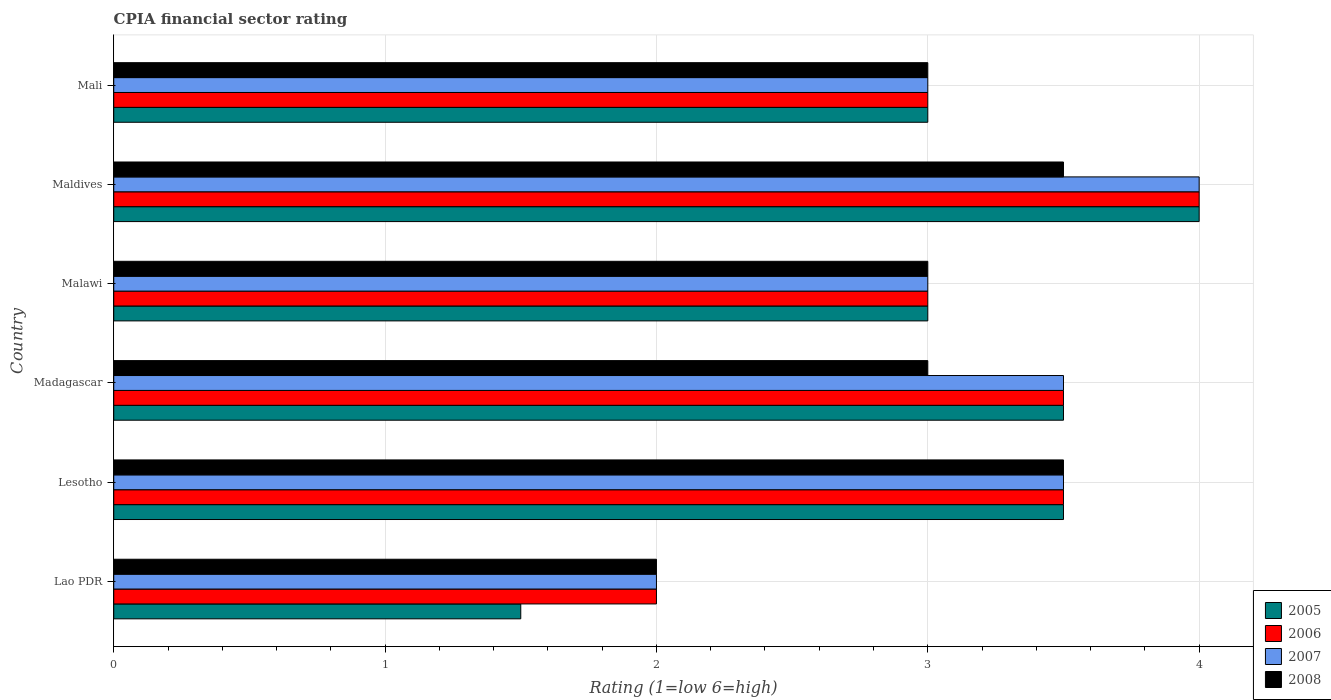How many different coloured bars are there?
Offer a very short reply. 4. How many groups of bars are there?
Your answer should be compact. 6. How many bars are there on the 5th tick from the bottom?
Provide a succinct answer. 4. What is the label of the 5th group of bars from the top?
Make the answer very short. Lesotho. What is the CPIA rating in 2007 in Lesotho?
Offer a terse response. 3.5. In which country was the CPIA rating in 2005 maximum?
Make the answer very short. Maldives. In which country was the CPIA rating in 2008 minimum?
Provide a succinct answer. Lao PDR. What is the total CPIA rating in 2008 in the graph?
Make the answer very short. 18. What is the difference between the CPIA rating in 2008 in Madagascar and that in Mali?
Offer a terse response. 0. What is the difference between the CPIA rating in 2008 in Maldives and the CPIA rating in 2006 in Madagascar?
Provide a short and direct response. 0. What is the difference between the CPIA rating in 2007 and CPIA rating in 2005 in Maldives?
Keep it short and to the point. 0. In how many countries, is the CPIA rating in 2006 greater than 1.8 ?
Offer a terse response. 6. What is the ratio of the CPIA rating in 2008 in Lesotho to that in Mali?
Give a very brief answer. 1.17. Is the CPIA rating in 2008 in Lesotho less than that in Madagascar?
Your response must be concise. No. What is the difference between the highest and the second highest CPIA rating in 2007?
Your answer should be very brief. 0.5. What is the difference between the highest and the lowest CPIA rating in 2006?
Ensure brevity in your answer.  2. Is it the case that in every country, the sum of the CPIA rating in 2005 and CPIA rating in 2006 is greater than the sum of CPIA rating in 2008 and CPIA rating in 2007?
Make the answer very short. No. What does the 1st bar from the top in Madagascar represents?
Your answer should be compact. 2008. What does the 2nd bar from the bottom in Madagascar represents?
Make the answer very short. 2006. What is the difference between two consecutive major ticks on the X-axis?
Your answer should be compact. 1. Where does the legend appear in the graph?
Keep it short and to the point. Bottom right. How many legend labels are there?
Your response must be concise. 4. What is the title of the graph?
Provide a succinct answer. CPIA financial sector rating. Does "1997" appear as one of the legend labels in the graph?
Keep it short and to the point. No. What is the label or title of the X-axis?
Give a very brief answer. Rating (1=low 6=high). What is the label or title of the Y-axis?
Your answer should be very brief. Country. What is the Rating (1=low 6=high) of 2005 in Lao PDR?
Make the answer very short. 1.5. What is the Rating (1=low 6=high) in 2006 in Lesotho?
Offer a terse response. 3.5. What is the Rating (1=low 6=high) in 2007 in Lesotho?
Ensure brevity in your answer.  3.5. What is the Rating (1=low 6=high) of 2005 in Madagascar?
Give a very brief answer. 3.5. What is the Rating (1=low 6=high) of 2006 in Madagascar?
Your response must be concise. 3.5. What is the Rating (1=low 6=high) in 2007 in Madagascar?
Give a very brief answer. 3.5. What is the Rating (1=low 6=high) of 2008 in Madagascar?
Provide a short and direct response. 3. What is the Rating (1=low 6=high) of 2005 in Malawi?
Ensure brevity in your answer.  3. What is the Rating (1=low 6=high) of 2007 in Malawi?
Make the answer very short. 3. What is the Rating (1=low 6=high) of 2008 in Malawi?
Give a very brief answer. 3. What is the Rating (1=low 6=high) of 2008 in Maldives?
Ensure brevity in your answer.  3.5. Across all countries, what is the maximum Rating (1=low 6=high) of 2005?
Give a very brief answer. 4. Across all countries, what is the maximum Rating (1=low 6=high) in 2006?
Ensure brevity in your answer.  4. Across all countries, what is the maximum Rating (1=low 6=high) in 2008?
Ensure brevity in your answer.  3.5. Across all countries, what is the minimum Rating (1=low 6=high) in 2006?
Provide a short and direct response. 2. Across all countries, what is the minimum Rating (1=low 6=high) in 2008?
Ensure brevity in your answer.  2. What is the total Rating (1=low 6=high) in 2005 in the graph?
Provide a short and direct response. 18.5. What is the total Rating (1=low 6=high) in 2006 in the graph?
Your answer should be compact. 19. What is the difference between the Rating (1=low 6=high) in 2005 in Lao PDR and that in Lesotho?
Give a very brief answer. -2. What is the difference between the Rating (1=low 6=high) in 2006 in Lao PDR and that in Lesotho?
Make the answer very short. -1.5. What is the difference between the Rating (1=low 6=high) in 2005 in Lao PDR and that in Madagascar?
Your answer should be compact. -2. What is the difference between the Rating (1=low 6=high) of 2008 in Lao PDR and that in Madagascar?
Your response must be concise. -1. What is the difference between the Rating (1=low 6=high) of 2006 in Lao PDR and that in Malawi?
Keep it short and to the point. -1. What is the difference between the Rating (1=low 6=high) of 2007 in Lao PDR and that in Malawi?
Provide a short and direct response. -1. What is the difference between the Rating (1=low 6=high) in 2008 in Lao PDR and that in Malawi?
Provide a succinct answer. -1. What is the difference between the Rating (1=low 6=high) of 2005 in Lao PDR and that in Maldives?
Offer a terse response. -2.5. What is the difference between the Rating (1=low 6=high) of 2006 in Lao PDR and that in Maldives?
Give a very brief answer. -2. What is the difference between the Rating (1=low 6=high) in 2007 in Lao PDR and that in Maldives?
Your answer should be compact. -2. What is the difference between the Rating (1=low 6=high) in 2008 in Lao PDR and that in Maldives?
Your response must be concise. -1.5. What is the difference between the Rating (1=low 6=high) of 2005 in Lao PDR and that in Mali?
Make the answer very short. -1.5. What is the difference between the Rating (1=low 6=high) in 2008 in Lao PDR and that in Mali?
Ensure brevity in your answer.  -1. What is the difference between the Rating (1=low 6=high) of 2005 in Lesotho and that in Madagascar?
Provide a succinct answer. 0. What is the difference between the Rating (1=low 6=high) of 2006 in Lesotho and that in Madagascar?
Ensure brevity in your answer.  0. What is the difference between the Rating (1=low 6=high) in 2008 in Lesotho and that in Madagascar?
Provide a succinct answer. 0.5. What is the difference between the Rating (1=low 6=high) in 2005 in Lesotho and that in Malawi?
Provide a short and direct response. 0.5. What is the difference between the Rating (1=low 6=high) in 2006 in Lesotho and that in Malawi?
Your answer should be compact. 0.5. What is the difference between the Rating (1=low 6=high) of 2005 in Lesotho and that in Maldives?
Offer a terse response. -0.5. What is the difference between the Rating (1=low 6=high) in 2008 in Lesotho and that in Maldives?
Provide a succinct answer. 0. What is the difference between the Rating (1=low 6=high) of 2006 in Lesotho and that in Mali?
Provide a succinct answer. 0.5. What is the difference between the Rating (1=low 6=high) in 2007 in Lesotho and that in Mali?
Make the answer very short. 0.5. What is the difference between the Rating (1=low 6=high) of 2005 in Madagascar and that in Malawi?
Your answer should be compact. 0.5. What is the difference between the Rating (1=low 6=high) in 2007 in Madagascar and that in Malawi?
Make the answer very short. 0.5. What is the difference between the Rating (1=low 6=high) in 2008 in Madagascar and that in Malawi?
Offer a very short reply. 0. What is the difference between the Rating (1=low 6=high) of 2005 in Madagascar and that in Maldives?
Provide a short and direct response. -0.5. What is the difference between the Rating (1=low 6=high) of 2006 in Madagascar and that in Maldives?
Your response must be concise. -0.5. What is the difference between the Rating (1=low 6=high) of 2007 in Madagascar and that in Maldives?
Provide a short and direct response. -0.5. What is the difference between the Rating (1=low 6=high) of 2008 in Madagascar and that in Maldives?
Keep it short and to the point. -0.5. What is the difference between the Rating (1=low 6=high) of 2005 in Madagascar and that in Mali?
Your answer should be very brief. 0.5. What is the difference between the Rating (1=low 6=high) in 2006 in Madagascar and that in Mali?
Your answer should be compact. 0.5. What is the difference between the Rating (1=low 6=high) of 2007 in Madagascar and that in Mali?
Your answer should be very brief. 0.5. What is the difference between the Rating (1=low 6=high) in 2005 in Malawi and that in Maldives?
Provide a short and direct response. -1. What is the difference between the Rating (1=low 6=high) in 2006 in Malawi and that in Maldives?
Ensure brevity in your answer.  -1. What is the difference between the Rating (1=low 6=high) of 2007 in Malawi and that in Maldives?
Make the answer very short. -1. What is the difference between the Rating (1=low 6=high) of 2005 in Malawi and that in Mali?
Your response must be concise. 0. What is the difference between the Rating (1=low 6=high) in 2007 in Malawi and that in Mali?
Offer a terse response. 0. What is the difference between the Rating (1=low 6=high) of 2008 in Malawi and that in Mali?
Keep it short and to the point. 0. What is the difference between the Rating (1=low 6=high) in 2005 in Maldives and that in Mali?
Your answer should be very brief. 1. What is the difference between the Rating (1=low 6=high) in 2006 in Maldives and that in Mali?
Ensure brevity in your answer.  1. What is the difference between the Rating (1=low 6=high) of 2007 in Maldives and that in Mali?
Your response must be concise. 1. What is the difference between the Rating (1=low 6=high) in 2008 in Maldives and that in Mali?
Ensure brevity in your answer.  0.5. What is the difference between the Rating (1=low 6=high) of 2005 in Lao PDR and the Rating (1=low 6=high) of 2006 in Lesotho?
Give a very brief answer. -2. What is the difference between the Rating (1=low 6=high) in 2005 in Lao PDR and the Rating (1=low 6=high) in 2007 in Lesotho?
Provide a succinct answer. -2. What is the difference between the Rating (1=low 6=high) of 2005 in Lao PDR and the Rating (1=low 6=high) of 2008 in Lesotho?
Your response must be concise. -2. What is the difference between the Rating (1=low 6=high) in 2006 in Lao PDR and the Rating (1=low 6=high) in 2008 in Lesotho?
Ensure brevity in your answer.  -1.5. What is the difference between the Rating (1=low 6=high) in 2007 in Lao PDR and the Rating (1=low 6=high) in 2008 in Lesotho?
Keep it short and to the point. -1.5. What is the difference between the Rating (1=low 6=high) in 2005 in Lao PDR and the Rating (1=low 6=high) in 2007 in Madagascar?
Offer a terse response. -2. What is the difference between the Rating (1=low 6=high) of 2005 in Lao PDR and the Rating (1=low 6=high) of 2008 in Madagascar?
Your answer should be compact. -1.5. What is the difference between the Rating (1=low 6=high) in 2006 in Lao PDR and the Rating (1=low 6=high) in 2007 in Madagascar?
Offer a terse response. -1.5. What is the difference between the Rating (1=low 6=high) of 2006 in Lao PDR and the Rating (1=low 6=high) of 2008 in Madagascar?
Offer a very short reply. -1. What is the difference between the Rating (1=low 6=high) in 2005 in Lao PDR and the Rating (1=low 6=high) in 2007 in Malawi?
Keep it short and to the point. -1.5. What is the difference between the Rating (1=low 6=high) in 2006 in Lao PDR and the Rating (1=low 6=high) in 2007 in Malawi?
Keep it short and to the point. -1. What is the difference between the Rating (1=low 6=high) in 2007 in Lao PDR and the Rating (1=low 6=high) in 2008 in Malawi?
Provide a short and direct response. -1. What is the difference between the Rating (1=low 6=high) in 2005 in Lao PDR and the Rating (1=low 6=high) in 2006 in Maldives?
Make the answer very short. -2.5. What is the difference between the Rating (1=low 6=high) of 2005 in Lao PDR and the Rating (1=low 6=high) of 2007 in Maldives?
Your answer should be very brief. -2.5. What is the difference between the Rating (1=low 6=high) of 2007 in Lao PDR and the Rating (1=low 6=high) of 2008 in Maldives?
Offer a very short reply. -1.5. What is the difference between the Rating (1=low 6=high) of 2005 in Lao PDR and the Rating (1=low 6=high) of 2006 in Mali?
Your answer should be compact. -1.5. What is the difference between the Rating (1=low 6=high) in 2006 in Lao PDR and the Rating (1=low 6=high) in 2007 in Mali?
Your answer should be compact. -1. What is the difference between the Rating (1=low 6=high) of 2006 in Lao PDR and the Rating (1=low 6=high) of 2008 in Mali?
Make the answer very short. -1. What is the difference between the Rating (1=low 6=high) of 2005 in Lesotho and the Rating (1=low 6=high) of 2006 in Madagascar?
Give a very brief answer. 0. What is the difference between the Rating (1=low 6=high) in 2005 in Lesotho and the Rating (1=low 6=high) in 2008 in Madagascar?
Your answer should be very brief. 0.5. What is the difference between the Rating (1=low 6=high) in 2006 in Lesotho and the Rating (1=low 6=high) in 2008 in Madagascar?
Offer a very short reply. 0.5. What is the difference between the Rating (1=low 6=high) in 2007 in Lesotho and the Rating (1=low 6=high) in 2008 in Madagascar?
Your answer should be compact. 0.5. What is the difference between the Rating (1=low 6=high) of 2005 in Lesotho and the Rating (1=low 6=high) of 2007 in Malawi?
Your answer should be compact. 0.5. What is the difference between the Rating (1=low 6=high) in 2006 in Lesotho and the Rating (1=low 6=high) in 2008 in Malawi?
Your response must be concise. 0.5. What is the difference between the Rating (1=low 6=high) in 2007 in Lesotho and the Rating (1=low 6=high) in 2008 in Malawi?
Provide a succinct answer. 0.5. What is the difference between the Rating (1=low 6=high) of 2005 in Lesotho and the Rating (1=low 6=high) of 2006 in Maldives?
Make the answer very short. -0.5. What is the difference between the Rating (1=low 6=high) of 2005 in Lesotho and the Rating (1=low 6=high) of 2007 in Maldives?
Your answer should be very brief. -0.5. What is the difference between the Rating (1=low 6=high) in 2005 in Lesotho and the Rating (1=low 6=high) in 2008 in Maldives?
Offer a very short reply. 0. What is the difference between the Rating (1=low 6=high) in 2006 in Lesotho and the Rating (1=low 6=high) in 2008 in Maldives?
Make the answer very short. 0. What is the difference between the Rating (1=low 6=high) in 2005 in Lesotho and the Rating (1=low 6=high) in 2006 in Mali?
Offer a terse response. 0.5. What is the difference between the Rating (1=low 6=high) in 2005 in Lesotho and the Rating (1=low 6=high) in 2007 in Mali?
Your answer should be compact. 0.5. What is the difference between the Rating (1=low 6=high) in 2006 in Lesotho and the Rating (1=low 6=high) in 2007 in Mali?
Make the answer very short. 0.5. What is the difference between the Rating (1=low 6=high) of 2006 in Lesotho and the Rating (1=low 6=high) of 2008 in Mali?
Make the answer very short. 0.5. What is the difference between the Rating (1=low 6=high) of 2005 in Madagascar and the Rating (1=low 6=high) of 2006 in Malawi?
Keep it short and to the point. 0.5. What is the difference between the Rating (1=low 6=high) of 2005 in Madagascar and the Rating (1=low 6=high) of 2006 in Maldives?
Your answer should be very brief. -0.5. What is the difference between the Rating (1=low 6=high) in 2007 in Madagascar and the Rating (1=low 6=high) in 2008 in Maldives?
Provide a short and direct response. 0. What is the difference between the Rating (1=low 6=high) in 2005 in Madagascar and the Rating (1=low 6=high) in 2006 in Mali?
Ensure brevity in your answer.  0.5. What is the difference between the Rating (1=low 6=high) in 2005 in Madagascar and the Rating (1=low 6=high) in 2007 in Mali?
Ensure brevity in your answer.  0.5. What is the difference between the Rating (1=low 6=high) of 2005 in Madagascar and the Rating (1=low 6=high) of 2008 in Mali?
Your response must be concise. 0.5. What is the difference between the Rating (1=low 6=high) of 2006 in Madagascar and the Rating (1=low 6=high) of 2007 in Mali?
Give a very brief answer. 0.5. What is the difference between the Rating (1=low 6=high) of 2006 in Madagascar and the Rating (1=low 6=high) of 2008 in Mali?
Make the answer very short. 0.5. What is the difference between the Rating (1=low 6=high) of 2007 in Madagascar and the Rating (1=low 6=high) of 2008 in Mali?
Keep it short and to the point. 0.5. What is the difference between the Rating (1=low 6=high) of 2005 in Malawi and the Rating (1=low 6=high) of 2006 in Maldives?
Provide a short and direct response. -1. What is the difference between the Rating (1=low 6=high) in 2005 in Malawi and the Rating (1=low 6=high) in 2007 in Maldives?
Provide a short and direct response. -1. What is the difference between the Rating (1=low 6=high) of 2005 in Malawi and the Rating (1=low 6=high) of 2008 in Maldives?
Provide a short and direct response. -0.5. What is the difference between the Rating (1=low 6=high) in 2006 in Malawi and the Rating (1=low 6=high) in 2007 in Maldives?
Your response must be concise. -1. What is the difference between the Rating (1=low 6=high) in 2006 in Malawi and the Rating (1=low 6=high) in 2008 in Maldives?
Your answer should be compact. -0.5. What is the difference between the Rating (1=low 6=high) of 2005 in Malawi and the Rating (1=low 6=high) of 2007 in Mali?
Offer a very short reply. 0. What is the difference between the Rating (1=low 6=high) in 2005 in Malawi and the Rating (1=low 6=high) in 2008 in Mali?
Your answer should be very brief. 0. What is the difference between the Rating (1=low 6=high) in 2006 in Malawi and the Rating (1=low 6=high) in 2008 in Mali?
Your answer should be very brief. 0. What is the difference between the Rating (1=low 6=high) of 2006 in Maldives and the Rating (1=low 6=high) of 2008 in Mali?
Your response must be concise. 1. What is the difference between the Rating (1=low 6=high) of 2007 in Maldives and the Rating (1=low 6=high) of 2008 in Mali?
Your answer should be compact. 1. What is the average Rating (1=low 6=high) of 2005 per country?
Keep it short and to the point. 3.08. What is the average Rating (1=low 6=high) in 2006 per country?
Your answer should be very brief. 3.17. What is the average Rating (1=low 6=high) of 2007 per country?
Ensure brevity in your answer.  3.17. What is the average Rating (1=low 6=high) in 2008 per country?
Provide a short and direct response. 3. What is the difference between the Rating (1=low 6=high) of 2005 and Rating (1=low 6=high) of 2006 in Lao PDR?
Keep it short and to the point. -0.5. What is the difference between the Rating (1=low 6=high) in 2006 and Rating (1=low 6=high) in 2008 in Lao PDR?
Keep it short and to the point. 0. What is the difference between the Rating (1=low 6=high) of 2007 and Rating (1=low 6=high) of 2008 in Lao PDR?
Provide a short and direct response. 0. What is the difference between the Rating (1=low 6=high) in 2005 and Rating (1=low 6=high) in 2006 in Lesotho?
Your response must be concise. 0. What is the difference between the Rating (1=low 6=high) in 2005 and Rating (1=low 6=high) in 2007 in Lesotho?
Provide a short and direct response. 0. What is the difference between the Rating (1=low 6=high) of 2005 and Rating (1=low 6=high) of 2008 in Lesotho?
Give a very brief answer. 0. What is the difference between the Rating (1=low 6=high) in 2006 and Rating (1=low 6=high) in 2008 in Lesotho?
Provide a succinct answer. 0. What is the difference between the Rating (1=low 6=high) of 2005 and Rating (1=low 6=high) of 2006 in Madagascar?
Offer a terse response. 0. What is the difference between the Rating (1=low 6=high) in 2006 and Rating (1=low 6=high) in 2007 in Madagascar?
Offer a very short reply. 0. What is the difference between the Rating (1=low 6=high) of 2006 and Rating (1=low 6=high) of 2008 in Madagascar?
Provide a succinct answer. 0.5. What is the difference between the Rating (1=low 6=high) in 2005 and Rating (1=low 6=high) in 2006 in Malawi?
Ensure brevity in your answer.  0. What is the difference between the Rating (1=low 6=high) in 2005 and Rating (1=low 6=high) in 2007 in Malawi?
Give a very brief answer. 0. What is the difference between the Rating (1=low 6=high) of 2005 and Rating (1=low 6=high) of 2006 in Maldives?
Provide a succinct answer. 0. What is the difference between the Rating (1=low 6=high) in 2006 and Rating (1=low 6=high) in 2007 in Maldives?
Make the answer very short. 0. What is the difference between the Rating (1=low 6=high) of 2006 and Rating (1=low 6=high) of 2008 in Maldives?
Offer a terse response. 0.5. What is the difference between the Rating (1=low 6=high) in 2005 and Rating (1=low 6=high) in 2007 in Mali?
Offer a very short reply. 0. What is the difference between the Rating (1=low 6=high) in 2006 and Rating (1=low 6=high) in 2008 in Mali?
Provide a succinct answer. 0. What is the difference between the Rating (1=low 6=high) of 2007 and Rating (1=low 6=high) of 2008 in Mali?
Your answer should be compact. 0. What is the ratio of the Rating (1=low 6=high) in 2005 in Lao PDR to that in Lesotho?
Your response must be concise. 0.43. What is the ratio of the Rating (1=low 6=high) of 2007 in Lao PDR to that in Lesotho?
Your answer should be compact. 0.57. What is the ratio of the Rating (1=low 6=high) of 2008 in Lao PDR to that in Lesotho?
Offer a very short reply. 0.57. What is the ratio of the Rating (1=low 6=high) of 2005 in Lao PDR to that in Madagascar?
Offer a terse response. 0.43. What is the ratio of the Rating (1=low 6=high) in 2006 in Lao PDR to that in Madagascar?
Your answer should be very brief. 0.57. What is the ratio of the Rating (1=low 6=high) of 2008 in Lao PDR to that in Madagascar?
Provide a succinct answer. 0.67. What is the ratio of the Rating (1=low 6=high) in 2005 in Lao PDR to that in Malawi?
Keep it short and to the point. 0.5. What is the ratio of the Rating (1=low 6=high) of 2006 in Lao PDR to that in Malawi?
Make the answer very short. 0.67. What is the ratio of the Rating (1=low 6=high) in 2008 in Lao PDR to that in Malawi?
Offer a terse response. 0.67. What is the ratio of the Rating (1=low 6=high) of 2005 in Lao PDR to that in Maldives?
Offer a terse response. 0.38. What is the ratio of the Rating (1=low 6=high) of 2008 in Lao PDR to that in Maldives?
Your answer should be very brief. 0.57. What is the ratio of the Rating (1=low 6=high) of 2006 in Lesotho to that in Madagascar?
Give a very brief answer. 1. What is the ratio of the Rating (1=low 6=high) in 2005 in Lesotho to that in Malawi?
Your response must be concise. 1.17. What is the ratio of the Rating (1=low 6=high) of 2007 in Lesotho to that in Malawi?
Provide a short and direct response. 1.17. What is the ratio of the Rating (1=low 6=high) in 2008 in Lesotho to that in Malawi?
Offer a terse response. 1.17. What is the ratio of the Rating (1=low 6=high) in 2005 in Lesotho to that in Maldives?
Your response must be concise. 0.88. What is the ratio of the Rating (1=low 6=high) of 2005 in Lesotho to that in Mali?
Keep it short and to the point. 1.17. What is the ratio of the Rating (1=low 6=high) in 2005 in Madagascar to that in Malawi?
Provide a short and direct response. 1.17. What is the ratio of the Rating (1=low 6=high) in 2006 in Madagascar to that in Malawi?
Your answer should be compact. 1.17. What is the ratio of the Rating (1=low 6=high) of 2007 in Madagascar to that in Malawi?
Your answer should be compact. 1.17. What is the ratio of the Rating (1=low 6=high) in 2005 in Madagascar to that in Maldives?
Make the answer very short. 0.88. What is the ratio of the Rating (1=low 6=high) of 2007 in Madagascar to that in Maldives?
Your answer should be very brief. 0.88. What is the ratio of the Rating (1=low 6=high) in 2008 in Madagascar to that in Maldives?
Make the answer very short. 0.86. What is the ratio of the Rating (1=low 6=high) in 2006 in Madagascar to that in Mali?
Your answer should be very brief. 1.17. What is the ratio of the Rating (1=low 6=high) of 2007 in Madagascar to that in Mali?
Give a very brief answer. 1.17. What is the ratio of the Rating (1=low 6=high) in 2007 in Malawi to that in Maldives?
Ensure brevity in your answer.  0.75. What is the ratio of the Rating (1=low 6=high) of 2008 in Malawi to that in Maldives?
Your answer should be very brief. 0.86. What is the ratio of the Rating (1=low 6=high) of 2005 in Malawi to that in Mali?
Your answer should be compact. 1. What is the ratio of the Rating (1=low 6=high) in 2005 in Maldives to that in Mali?
Keep it short and to the point. 1.33. What is the ratio of the Rating (1=low 6=high) in 2007 in Maldives to that in Mali?
Keep it short and to the point. 1.33. What is the difference between the highest and the second highest Rating (1=low 6=high) in 2005?
Make the answer very short. 0.5. What is the difference between the highest and the second highest Rating (1=low 6=high) in 2007?
Provide a succinct answer. 0.5. What is the difference between the highest and the second highest Rating (1=low 6=high) in 2008?
Ensure brevity in your answer.  0. What is the difference between the highest and the lowest Rating (1=low 6=high) in 2005?
Your response must be concise. 2.5. What is the difference between the highest and the lowest Rating (1=low 6=high) of 2007?
Keep it short and to the point. 2. What is the difference between the highest and the lowest Rating (1=low 6=high) of 2008?
Provide a succinct answer. 1.5. 